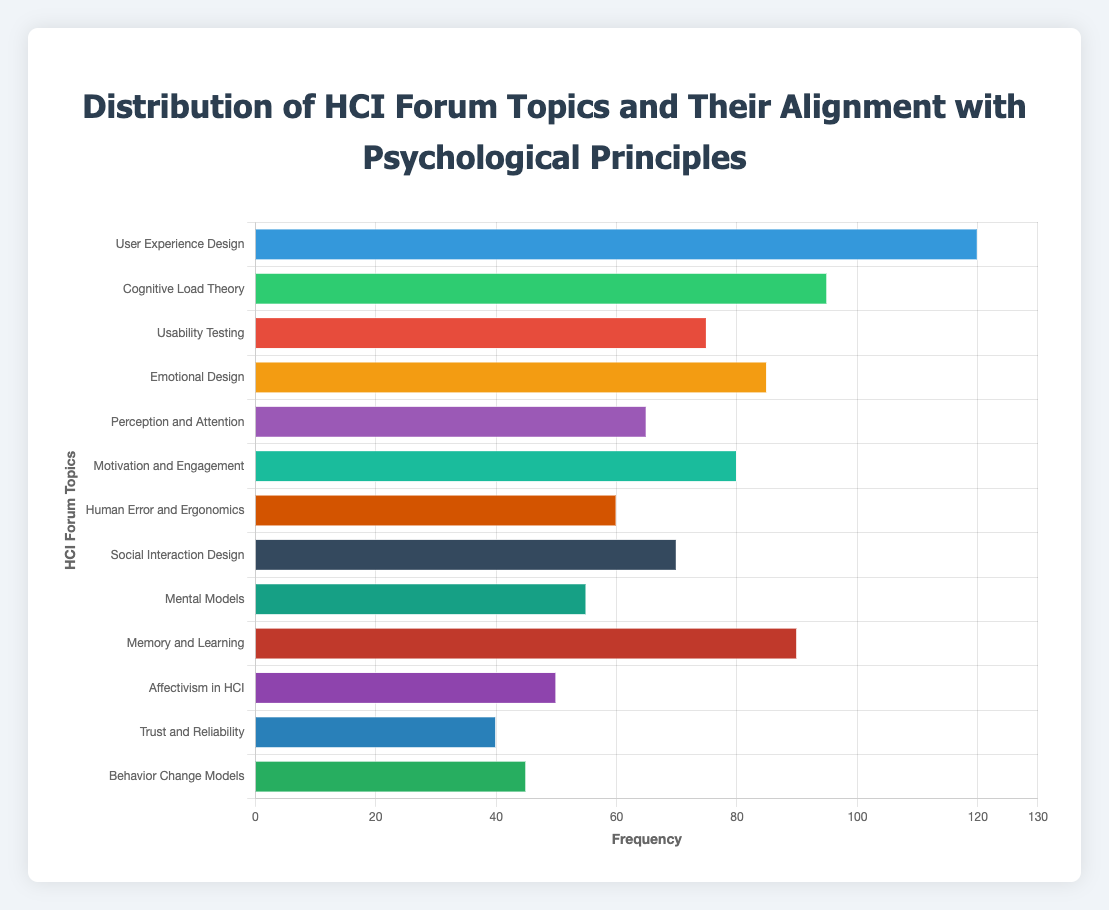Which HCI forum topic has the highest frequency? The bar chart shows the frequency of each HCI forum topic, with "User Experience Design" having the longest bar.
Answer: User Experience Design What's the sum of the frequencies of "Cognitive Load Theory" and "Memory and Learning"? Add the frequencies of "Cognitive Load Theory" (95) and "Memory and Learning" (90). 95 + 90 = 185
Answer: 185 Which topic has a higher frequency: "Emotional Design" or "Motivation and Engagement"? Compare the bar lengths of "Emotional Design" (85) and "Motivation and Engagement" (80). "Emotional Design" has a higher frequency.
Answer: Emotional Design What is the frequency difference between "Usability Testing" and "Social Interaction Design"? Subtract the frequency of "Social Interaction Design" (70) from "Usability Testing" (75). 75 - 70 = 5
Answer: 5 Which topic is less frequent, "Affectivism in HCI" or "Trust and Reliability"? Compare the bar lengths of "Affectivism in HCI" (50) and "Trust and Reliability" (40). "Trust and Reliability" is less frequent.
Answer: Trust and Reliability What is the average frequency of the topics by adding "Human Error and Ergonomics", "Mental Models", and "Behavior Change Models"? Add the frequencies of the three topics: "Human Error and Ergonomics" (60), "Mental Models" (55), and "Behavior Change Models" (45), then divide by 3. (60 + 55 + 45) / 3 = 160 / 3 ≈ 53.33
Answer: 53.33 How many topics have a frequency greater than 70? Identify and count the topics with frequencies greater than 70: "User Experience Design" (120), "Cognitive Load Theory" (95), "Emotional Design" (85), "Motivation and Engagement" (80), "Memory and Learning" (90). There are 5 such topics.
Answer: 5 What is the cumulative frequency of the five most frequent topics? Sum the frequencies of the top five topics: "User Experience Design" (120), "Cognitive Load Theory" (95), "Memory and Learning" (90), "Emotional Design" (85), "Motivation and Engagement" (80). 120 + 95 + 90 + 85 + 80 = 470
Answer: 470 Which topic has the shortest bar length indicating the lowest frequency? The topic with the shortest bar is "Trust and Reliability" with a frequency of 40.
Answer: Trust and Reliability 